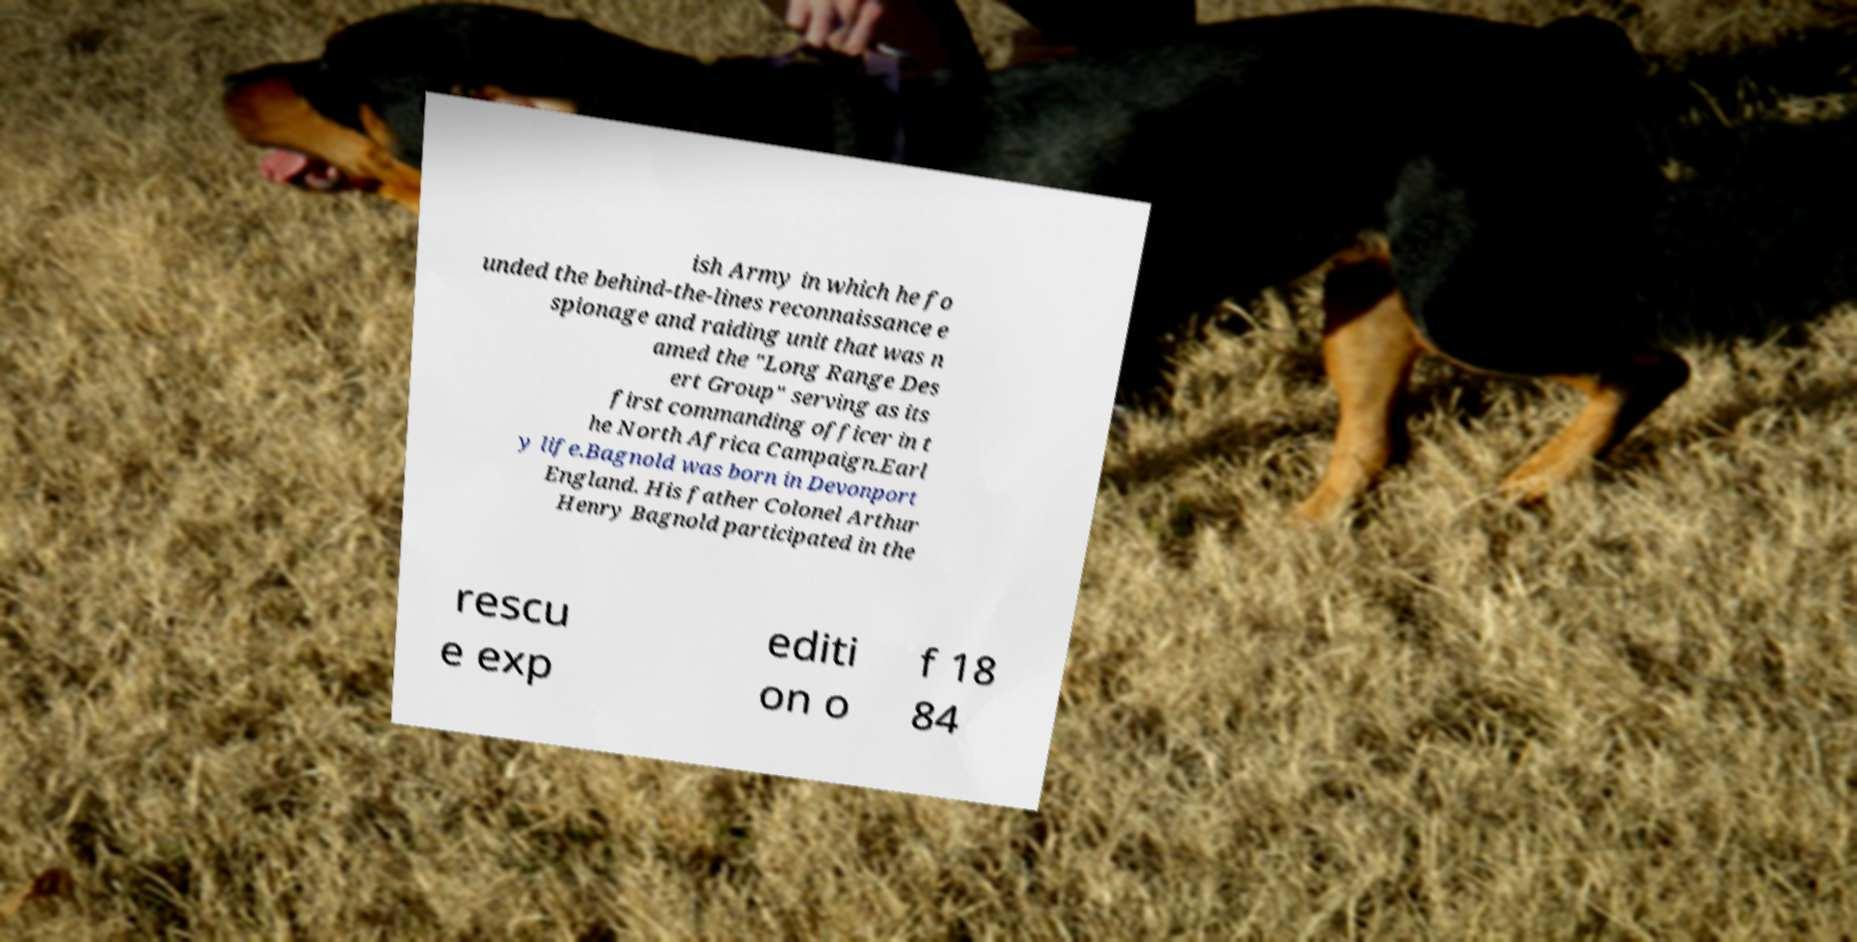Can you read and provide the text displayed in the image?This photo seems to have some interesting text. Can you extract and type it out for me? ish Army in which he fo unded the behind-the-lines reconnaissance e spionage and raiding unit that was n amed the "Long Range Des ert Group" serving as its first commanding officer in t he North Africa Campaign.Earl y life.Bagnold was born in Devonport England. His father Colonel Arthur Henry Bagnold participated in the rescu e exp editi on o f 18 84 